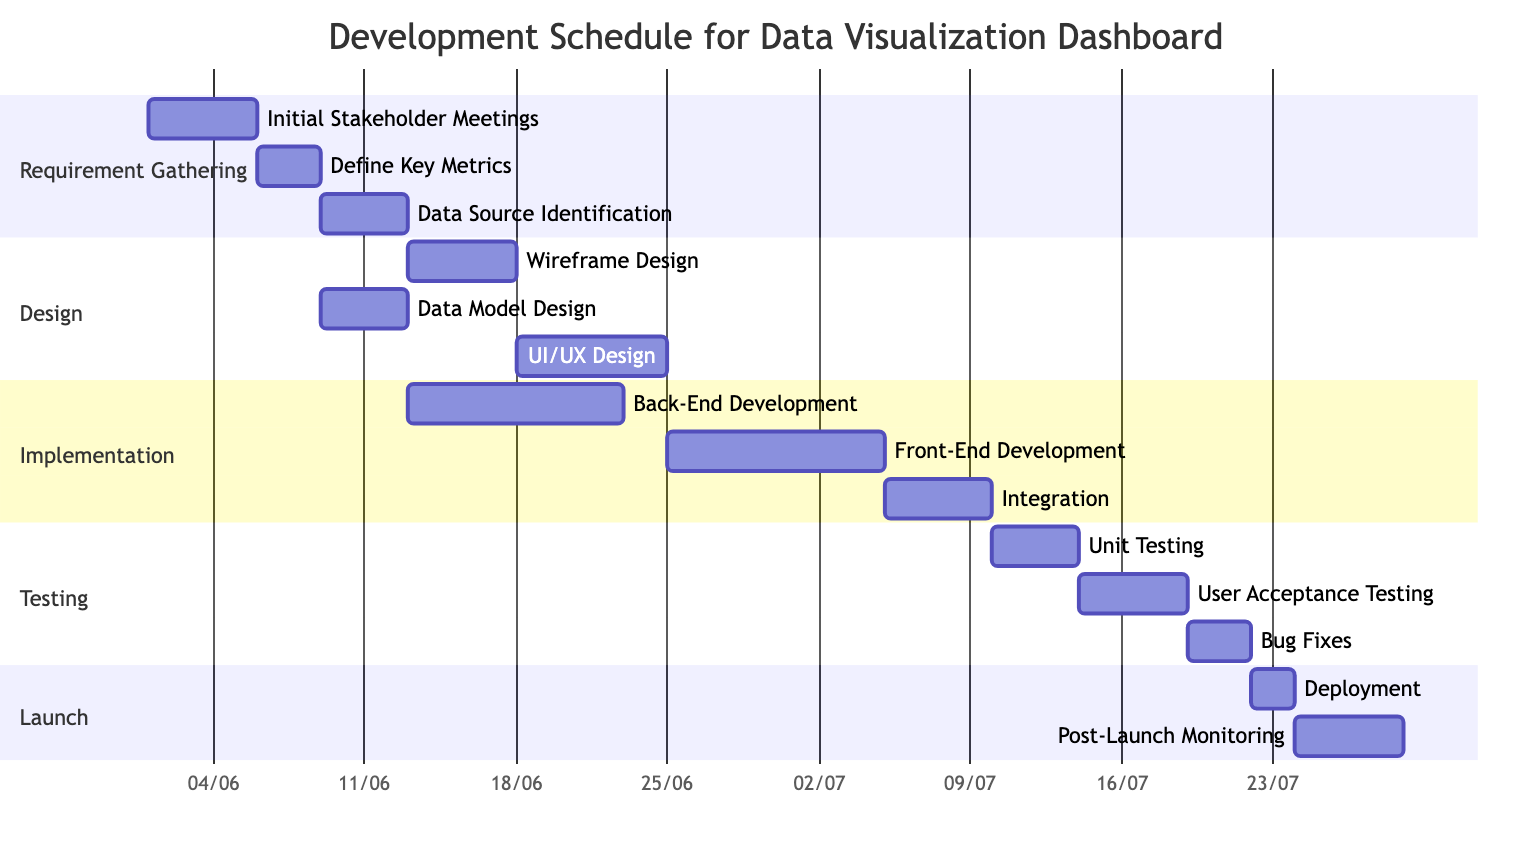What is the duration of the "Data Model Design" task? The "Data Model Design" task is represented in the Design section of the diagram, and its duration is specified as "4 days".
Answer: 4 days How many tasks are there in the "Testing" phase? In the Testing phase, there are three tasks listed: Unit Testing, User Acceptance Testing, and Bug Fixes, totaling three tasks.
Answer: 3 tasks What is the dependency for "UI/UX Design"? The task "UI/UX Design" depends on the task "Wireframe Design" as indicated in the diagram.
Answer: Wireframe Design Which task follows "Integration"? In the Testing section, the task that follows "Integration" is "Unit Testing", as per the order of tasks in the diagram.
Answer: Unit Testing How long does the entire "Implementation" phase take? The Implementation phase has three tasks—Back-End Development (10 days), Front-End Development (10 days), and Integration (5 days). The duration is calculated as the total of these tasks, where Integration starts after both Back-End and Front-End Development are completed in parallel. Therefore, the longest task determines the implementation duration: 10 + 5 = 15 days.
Answer: 15 days What is the last task in the "Launch" section? The final task listed in the Launch section of the diagram is "Post-Launch Monitoring".
Answer: Post-Launch Monitoring How many days does the "Deployment" task take? The "Deployment" task is explicitly stated in the Launch section to take "2 days".
Answer: 2 days Which two tasks must be completed before "User Acceptance Testing"? "Unit Testing" must follow "Integration," and since "User Acceptance Testing" depends on "Unit Testing", the tasks that must be completed are "Integration" and "Unit Testing".
Answer: Integration, Unit Testing What is the total duration of the "Design" phase? The Design phase includes three tasks: Wireframe Design (5 days), Data Model Design (4 days), and UI/UX Design (7 days). The total duration is driven by the longest task sequence: Wireframe Design (5 days) and UI/UX Design after it (7 days), resulting in: 5 + 7 = 12 days.
Answer: 12 days 